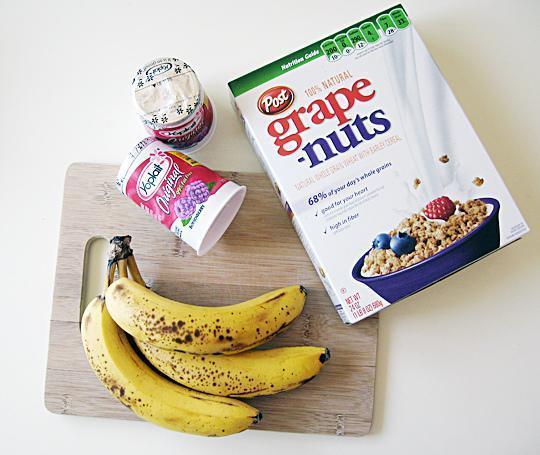How many cups are in the photo?
Give a very brief answer. 2. How many people are sitting down?
Give a very brief answer. 0. 